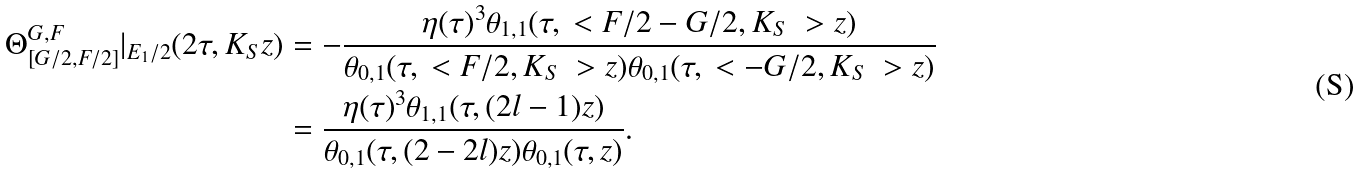Convert formula to latex. <formula><loc_0><loc_0><loc_500><loc_500>\Theta ^ { G , F } _ { [ G / 2 , F / 2 ] } | _ { E _ { 1 } / 2 } ( 2 \tau , K _ { S } z ) & = - \frac { \eta ( \tau ) ^ { 3 } \theta _ { 1 , 1 } ( \tau , \ < F / 2 - G / 2 , K _ { S } \ > z ) } { \theta _ { 0 , 1 } ( \tau , \ < F / 2 , K _ { S } \ > z ) \theta _ { 0 , 1 } ( \tau , \ < - G / 2 , K _ { S } \ > z ) } \\ & = \frac { \eta ( \tau ) ^ { 3 } \theta _ { 1 , 1 } ( \tau , ( 2 l - 1 ) z ) } { \theta _ { 0 , 1 } ( \tau , ( 2 - 2 l ) z ) \theta _ { 0 , 1 } ( \tau , z ) } .</formula> 